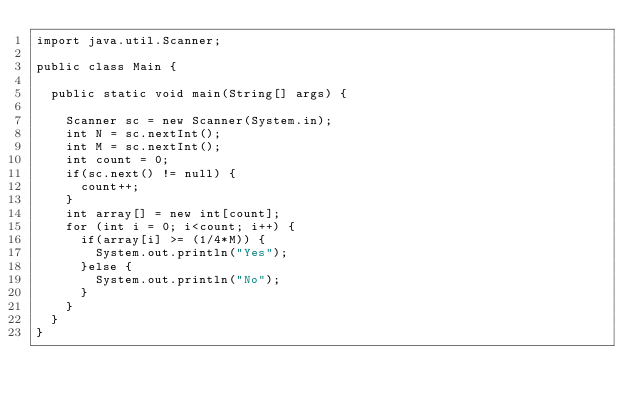Convert code to text. <code><loc_0><loc_0><loc_500><loc_500><_Java_>import java.util.Scanner;

public class Main {

	public static void main(String[] args) {

		Scanner sc = new Scanner(System.in);
		int N = sc.nextInt();
		int M = sc.nextInt();
		int count = 0;
		if(sc.next() != null) {
			count++;
		}
		int array[] = new int[count];
		for (int i = 0; i<count; i++) {
			if(array[i] >= (1/4*M)) {
				System.out.println("Yes");
			}else {
				System.out.println("No");
			}
		}
	}
}</code> 